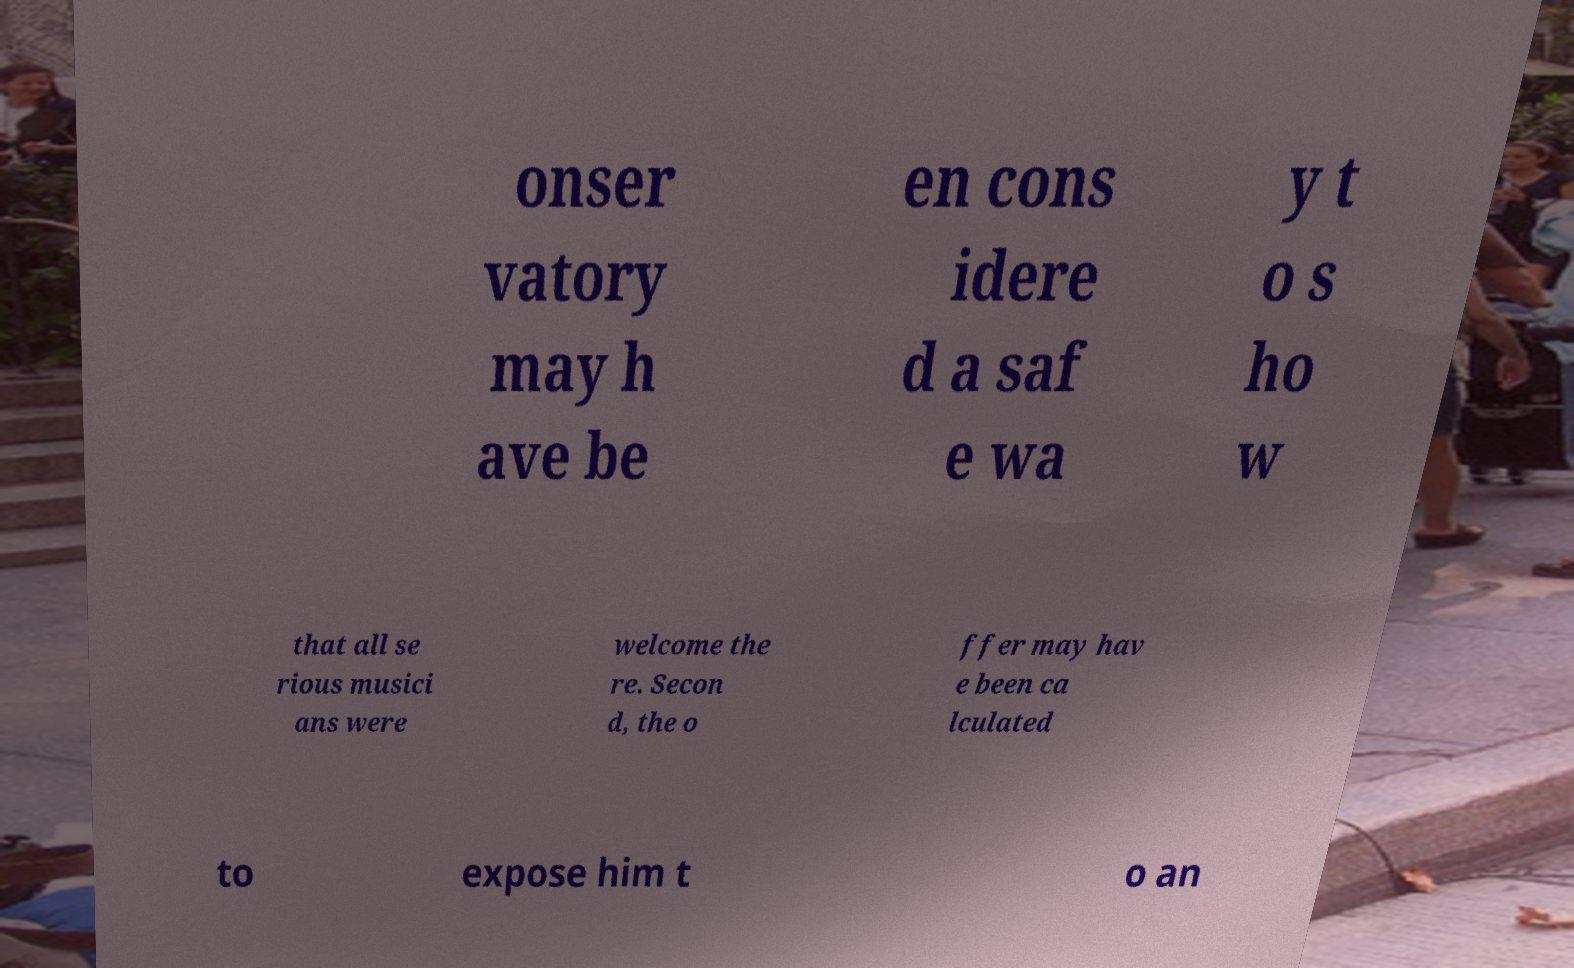Can you accurately transcribe the text from the provided image for me? onser vatory may h ave be en cons idere d a saf e wa y t o s ho w that all se rious musici ans were welcome the re. Secon d, the o ffer may hav e been ca lculated to expose him t o an 